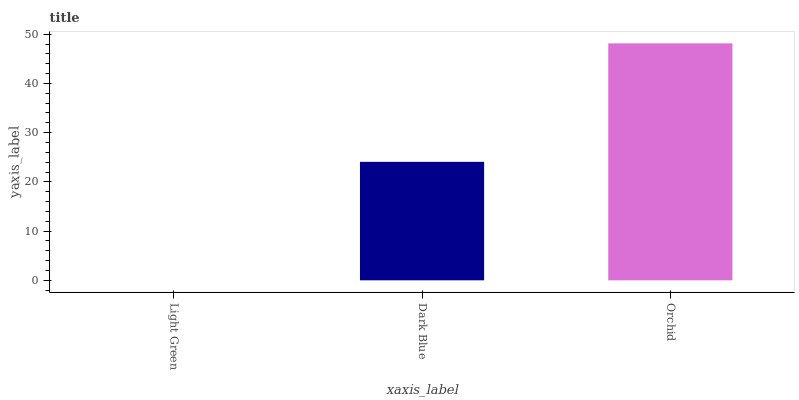Is Light Green the minimum?
Answer yes or no. Yes. Is Orchid the maximum?
Answer yes or no. Yes. Is Dark Blue the minimum?
Answer yes or no. No. Is Dark Blue the maximum?
Answer yes or no. No. Is Dark Blue greater than Light Green?
Answer yes or no. Yes. Is Light Green less than Dark Blue?
Answer yes or no. Yes. Is Light Green greater than Dark Blue?
Answer yes or no. No. Is Dark Blue less than Light Green?
Answer yes or no. No. Is Dark Blue the high median?
Answer yes or no. Yes. Is Dark Blue the low median?
Answer yes or no. Yes. Is Orchid the high median?
Answer yes or no. No. Is Light Green the low median?
Answer yes or no. No. 